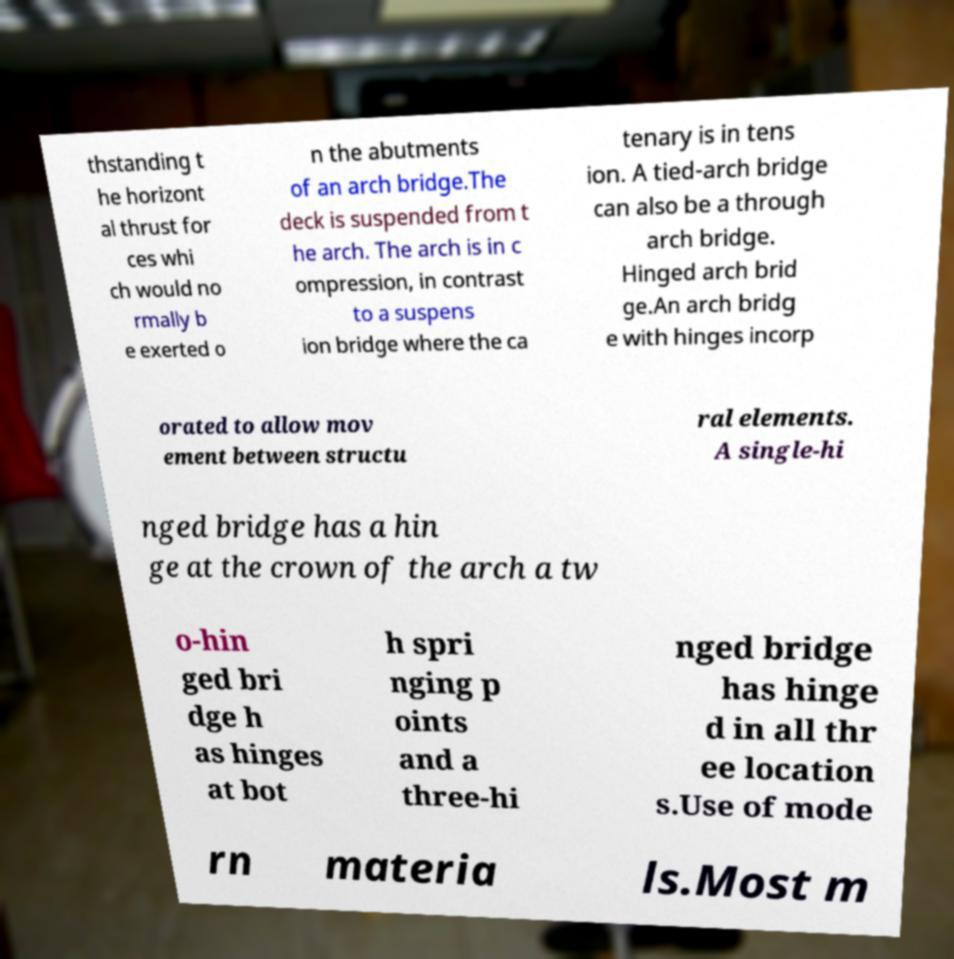For documentation purposes, I need the text within this image transcribed. Could you provide that? thstanding t he horizont al thrust for ces whi ch would no rmally b e exerted o n the abutments of an arch bridge.The deck is suspended from t he arch. The arch is in c ompression, in contrast to a suspens ion bridge where the ca tenary is in tens ion. A tied-arch bridge can also be a through arch bridge. Hinged arch brid ge.An arch bridg e with hinges incorp orated to allow mov ement between structu ral elements. A single-hi nged bridge has a hin ge at the crown of the arch a tw o-hin ged bri dge h as hinges at bot h spri nging p oints and a three-hi nged bridge has hinge d in all thr ee location s.Use of mode rn materia ls.Most m 